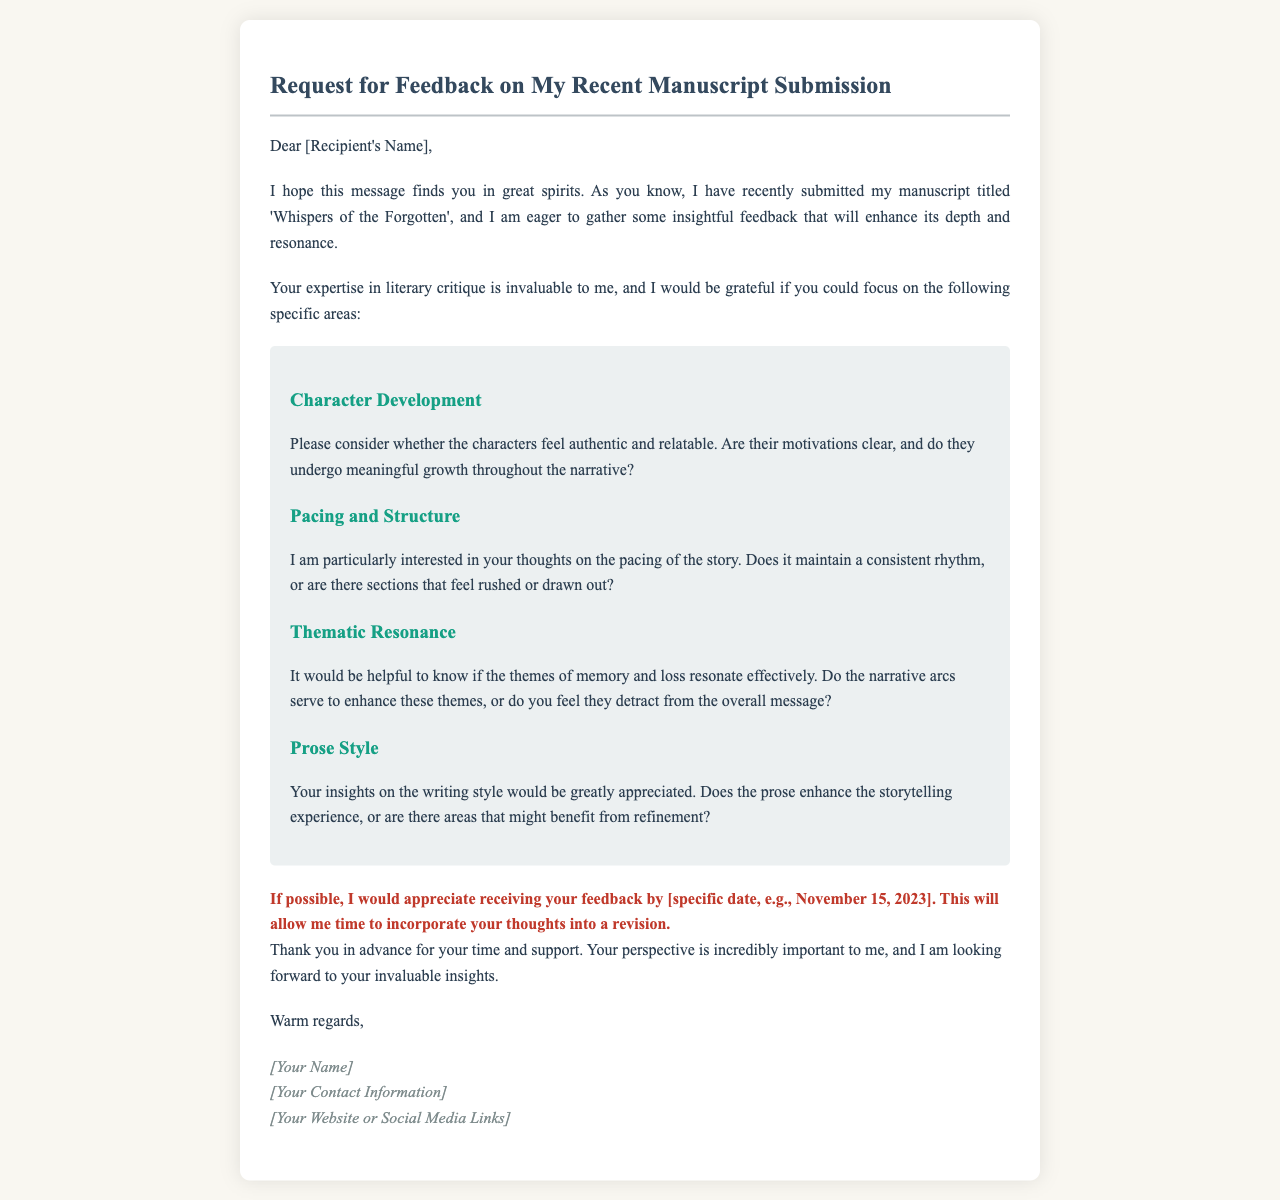What is the title of the manuscript? The title of the manuscript is stated in the introduction section.
Answer: Whispers of the Forgotten What are the four areas of critique requested? The areas of critique are listed in the critique section of the email.
Answer: Character Development, Pacing and Structure, Thematic Resonance, Prose Style By when is feedback requested? The deadline for feedback is explicitly mentioned in the email.
Answer: November 15, 2023 Who is the email addressed to? The recipient's name is specified in the greeting of the email.
Answer: [Recipient's Name] What writing style does the author use in the email? The style can be inferred from the presentation and tone of the email.
Answer: Formal and respectful Is the author open to feedback? The tone of the email suggests openness to suggestions.
Answer: Yes What kind of support is the author seeking? The author indicates the type of assistance they are looking for in their request.
Answer: Insightful feedback What color is used for the critique areas' background? The background color for the critique areas is specified in the email structure.
Answer: Light gray (ecf0f1) 